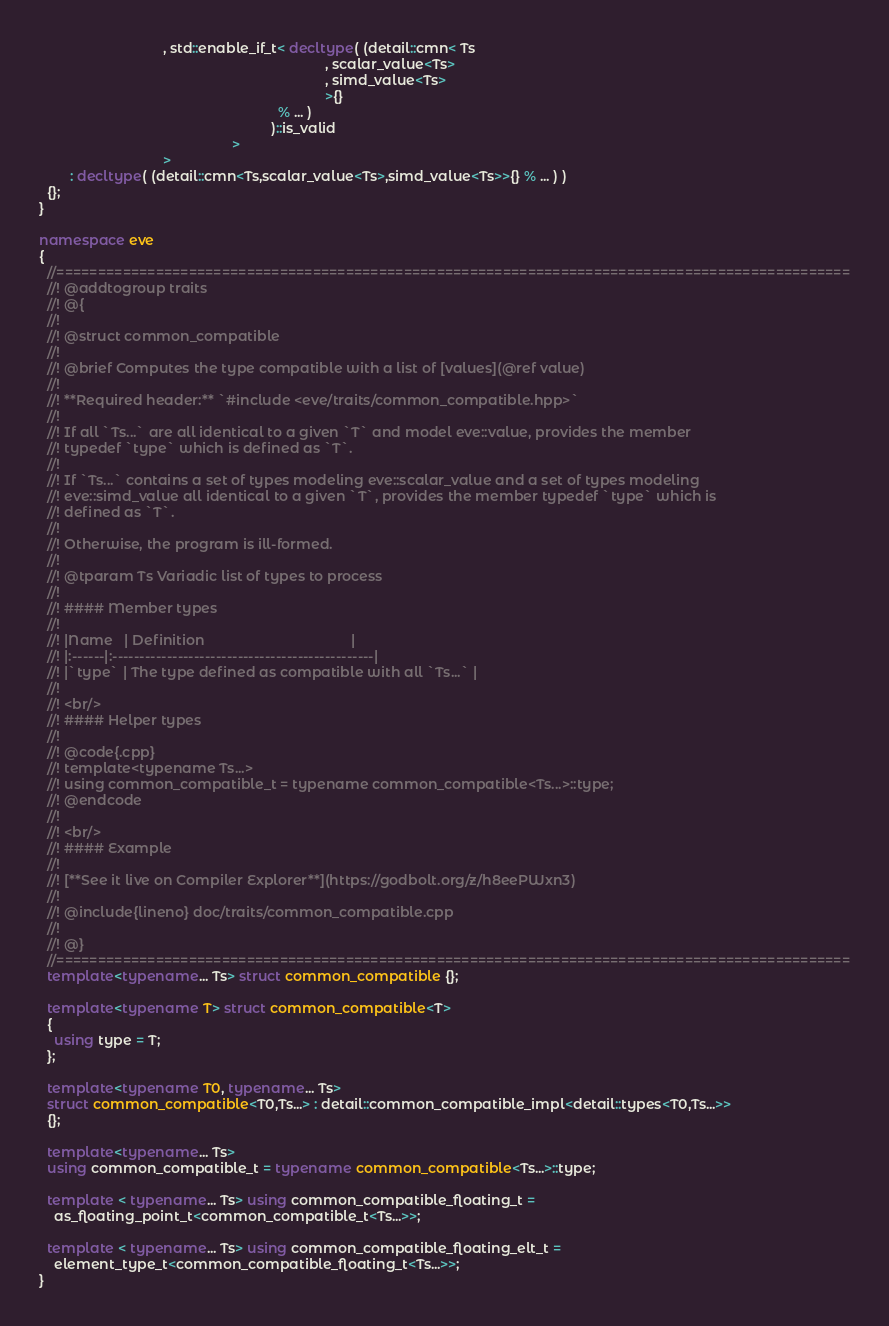Convert code to text. <code><loc_0><loc_0><loc_500><loc_500><_C++_>                                , std::enable_if_t< decltype( (detail::cmn< Ts
                                                                          , scalar_value<Ts>
                                                                          , simd_value<Ts>
                                                                          >{}
                                                              % ... )
                                                            )::is_valid
                                                  >
                                >
        : decltype( (detail::cmn<Ts,scalar_value<Ts>,simd_value<Ts>>{} % ... ) )
  {};
}

namespace eve
{
  //================================================================================================
  //! @addtogroup traits
  //! @{
  //!
  //! @struct common_compatible
  //!
  //! @brief Computes the type compatible with a list of [values](@ref value)
  //!
  //! **Required header:** `#include <eve/traits/common_compatible.hpp>`
  //!
  //! If all `Ts...` are all identical to a given `T` and model eve::value, provides the member
  //! typedef `type` which is defined as `T`.
  //!
  //! If `Ts...` contains a set of types modeling eve::scalar_value and a set of types modeling
  //! eve::simd_value all identical to a given `T`, provides the member typedef `type` which is
  //! defined as `T`.
  //!
  //! Otherwise, the program is ill-formed.
  //!
  //! @tparam Ts Variadic list of types to process
  //!
  //! #### Member types
  //!
  //! |Name   | Definition                                      |
  //! |:------|:------------------------------------------------|
  //! |`type` | The type defined as compatible with all `Ts...` |
  //!
  //! <br/>
  //! #### Helper types
  //!
  //! @code{.cpp}
  //! template<typename Ts...>
  //! using common_compatible_t = typename common_compatible<Ts...>::type;
  //! @endcode
  //!
  //! <br/>
  //! #### Example
  //!
  //! [**See it live on Compiler Explorer**](https://godbolt.org/z/h8eePWxn3)
  //!
  //! @include{lineno} doc/traits/common_compatible.cpp
  //!
  //! @}
  //================================================================================================
  template<typename... Ts> struct common_compatible {};

  template<typename T> struct common_compatible<T>
  {
    using type = T;
  };

  template<typename T0, typename... Ts>
  struct common_compatible<T0,Ts...> : detail::common_compatible_impl<detail::types<T0,Ts...>>
  {};

  template<typename... Ts>
  using common_compatible_t = typename common_compatible<Ts...>::type;

  template < typename... Ts> using common_compatible_floating_t =
    as_floating_point_t<common_compatible_t<Ts...>>;

  template < typename... Ts> using common_compatible_floating_elt_t =
    element_type_t<common_compatible_floating_t<Ts...>>;
}
</code> 